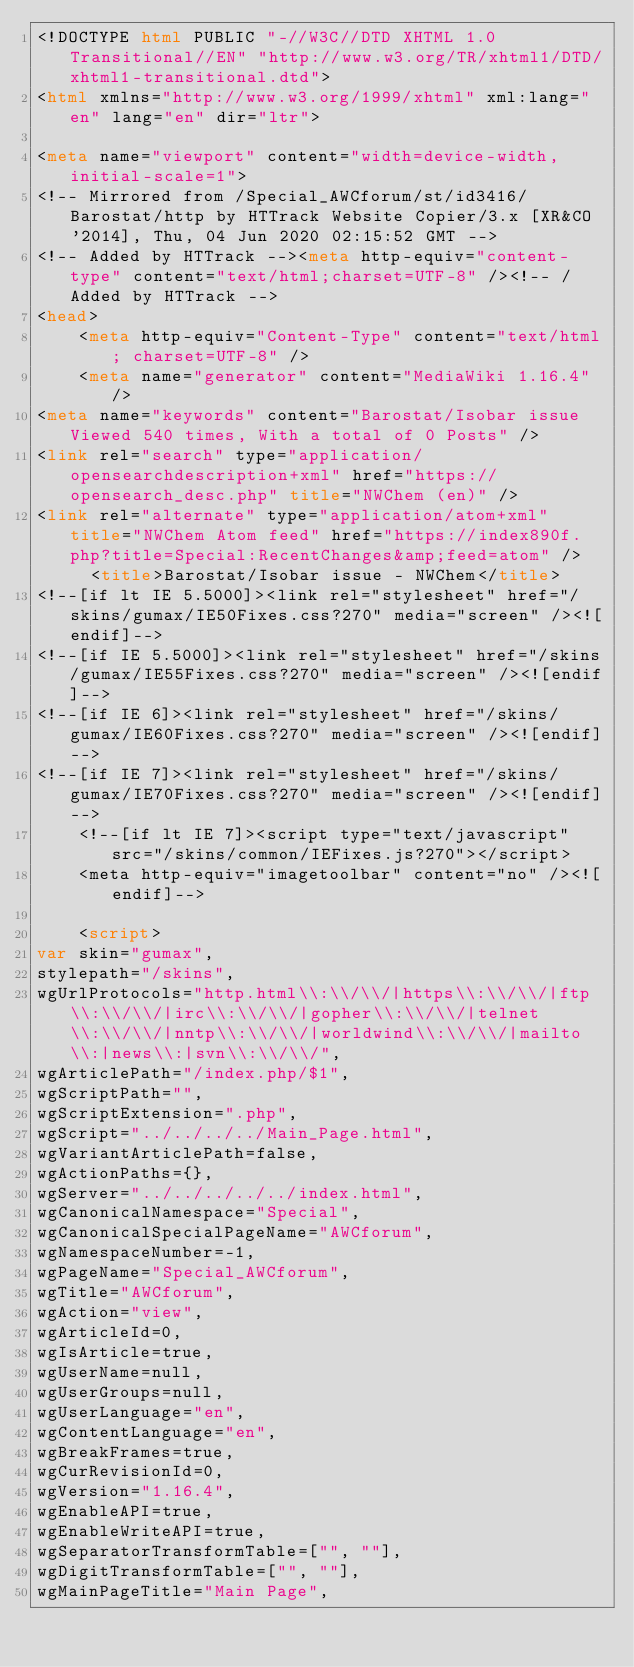Convert code to text. <code><loc_0><loc_0><loc_500><loc_500><_HTML_><!DOCTYPE html PUBLIC "-//W3C//DTD XHTML 1.0 Transitional//EN" "http://www.w3.org/TR/xhtml1/DTD/xhtml1-transitional.dtd">
<html xmlns="http://www.w3.org/1999/xhtml" xml:lang="en" lang="en" dir="ltr">
	
<meta name="viewport" content="width=device-width, initial-scale=1">
<!-- Mirrored from /Special_AWCforum/st/id3416/Barostat/http by HTTrack Website Copier/3.x [XR&CO'2014], Thu, 04 Jun 2020 02:15:52 GMT -->
<!-- Added by HTTrack --><meta http-equiv="content-type" content="text/html;charset=UTF-8" /><!-- /Added by HTTrack -->
<head>
		<meta http-equiv="Content-Type" content="text/html; charset=UTF-8" />
		<meta name="generator" content="MediaWiki 1.16.4" />
<meta name="keywords" content="Barostat/Isobar issue Viewed 540 times, With a total of 0 Posts" />
<link rel="search" type="application/opensearchdescription+xml" href="https://opensearch_desc.php" title="NWChem (en)" />
<link rel="alternate" type="application/atom+xml" title="NWChem Atom feed" href="https://index890f.php?title=Special:RecentChanges&amp;feed=atom" />		<title>Barostat/Isobar issue - NWChem</title>
<!--[if lt IE 5.5000]><link rel="stylesheet" href="/skins/gumax/IE50Fixes.css?270" media="screen" /><![endif]-->
<!--[if IE 5.5000]><link rel="stylesheet" href="/skins/gumax/IE55Fixes.css?270" media="screen" /><![endif]-->
<!--[if IE 6]><link rel="stylesheet" href="/skins/gumax/IE60Fixes.css?270" media="screen" /><![endif]-->
<!--[if IE 7]><link rel="stylesheet" href="/skins/gumax/IE70Fixes.css?270" media="screen" /><![endif]-->
		<!--[if lt IE 7]><script type="text/javascript" src="/skins/common/IEFixes.js?270"></script>
		<meta http-equiv="imagetoolbar" content="no" /><![endif]-->

		<script>
var skin="gumax",
stylepath="/skins",
wgUrlProtocols="http.html\\:\\/\\/|https\\:\\/\\/|ftp\\:\\/\\/|irc\\:\\/\\/|gopher\\:\\/\\/|telnet\\:\\/\\/|nntp\\:\\/\\/|worldwind\\:\\/\\/|mailto\\:|news\\:|svn\\:\\/\\/",
wgArticlePath="/index.php/$1",
wgScriptPath="",
wgScriptExtension=".php",
wgScript="../../../../Main_Page.html",
wgVariantArticlePath=false,
wgActionPaths={},
wgServer="../../../../../index.html",
wgCanonicalNamespace="Special",
wgCanonicalSpecialPageName="AWCforum",
wgNamespaceNumber=-1,
wgPageName="Special_AWCforum",
wgTitle="AWCforum",
wgAction="view",
wgArticleId=0,
wgIsArticle=true,
wgUserName=null,
wgUserGroups=null,
wgUserLanguage="en",
wgContentLanguage="en",
wgBreakFrames=true,
wgCurRevisionId=0,
wgVersion="1.16.4",
wgEnableAPI=true,
wgEnableWriteAPI=true,
wgSeparatorTransformTable=["", ""],
wgDigitTransformTable=["", ""],
wgMainPageTitle="Main Page",</code> 